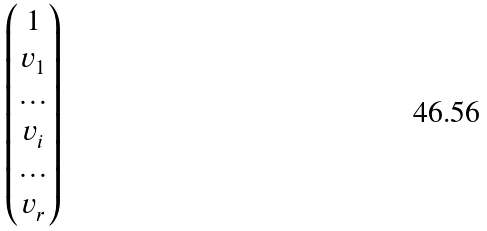Convert formula to latex. <formula><loc_0><loc_0><loc_500><loc_500>\begin{pmatrix} 1 \\ v _ { 1 } \\ \hdots \\ v _ { i } \\ \hdots \\ v _ { r } \end{pmatrix}</formula> 